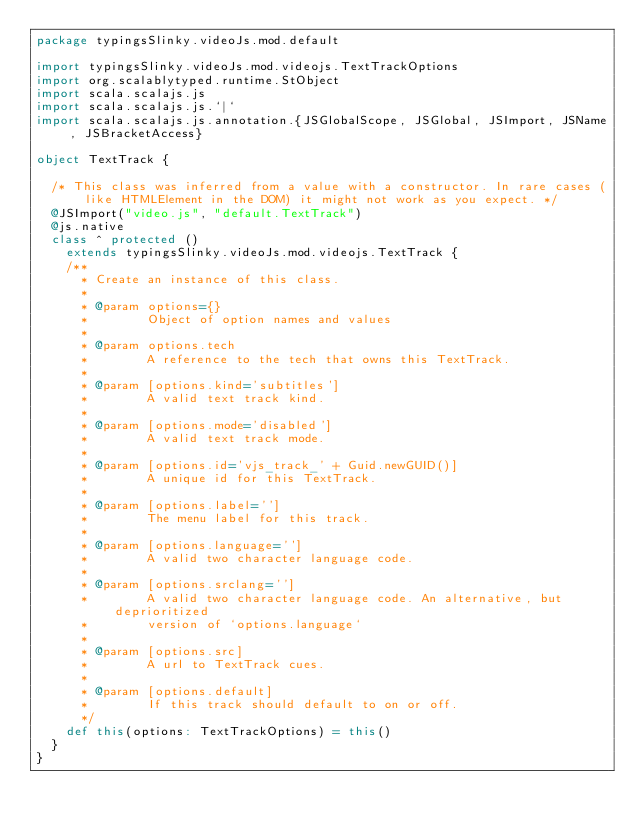Convert code to text. <code><loc_0><loc_0><loc_500><loc_500><_Scala_>package typingsSlinky.videoJs.mod.default

import typingsSlinky.videoJs.mod.videojs.TextTrackOptions
import org.scalablytyped.runtime.StObject
import scala.scalajs.js
import scala.scalajs.js.`|`
import scala.scalajs.js.annotation.{JSGlobalScope, JSGlobal, JSImport, JSName, JSBracketAccess}

object TextTrack {
  
  /* This class was inferred from a value with a constructor. In rare cases (like HTMLElement in the DOM) it might not work as you expect. */
  @JSImport("video.js", "default.TextTrack")
  @js.native
  class ^ protected ()
    extends typingsSlinky.videoJs.mod.videojs.TextTrack {
    /**
      * Create an instance of this class.
      *
      * @param options={}
      *        Object of option names and values
      *
      * @param options.tech
      *        A reference to the tech that owns this TextTrack.
      *
      * @param [options.kind='subtitles']
      *        A valid text track kind.
      *
      * @param [options.mode='disabled']
      *        A valid text track mode.
      *
      * @param [options.id='vjs_track_' + Guid.newGUID()]
      *        A unique id for this TextTrack.
      *
      * @param [options.label='']
      *        The menu label for this track.
      *
      * @param [options.language='']
      *        A valid two character language code.
      *
      * @param [options.srclang='']
      *        A valid two character language code. An alternative, but deprioritized
      *        version of `options.language`
      *
      * @param [options.src]
      *        A url to TextTrack cues.
      *
      * @param [options.default]
      *        If this track should default to on or off.
      */
    def this(options: TextTrackOptions) = this()
  }
}
</code> 